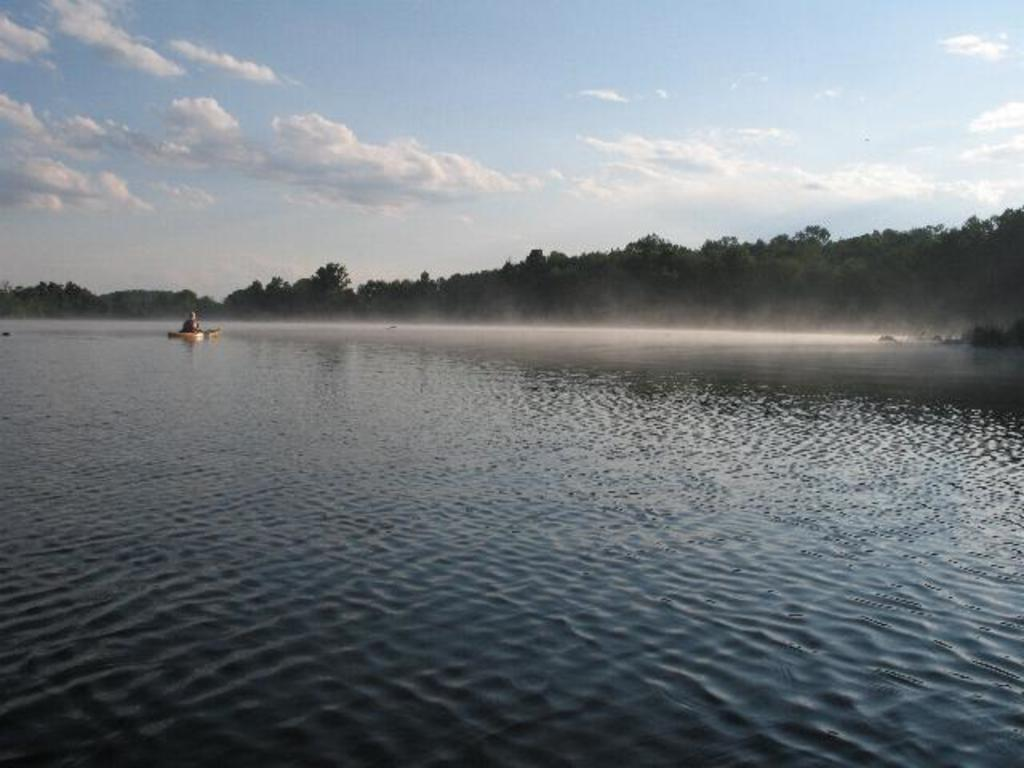What is the person in the image doing? The person is sitting on a boat in the image. Where is the boat located? The boat is on the water. What can be seen in the background of the image? There are trees and the sky visible in the background of the image. What type of dolls are scattered around the yard in the morning in the image? There are no dolls or yards present in the image; it features a person sitting on a boat on the water. 